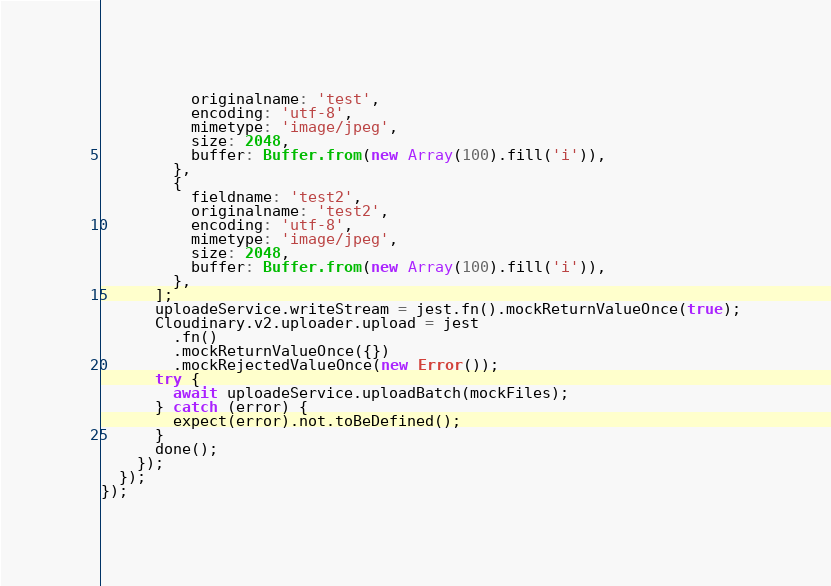Convert code to text. <code><loc_0><loc_0><loc_500><loc_500><_TypeScript_>          originalname: 'test',
          encoding: 'utf-8',
          mimetype: 'image/jpeg',
          size: 2048,
          buffer: Buffer.from(new Array(100).fill('i')),
        },
        {
          fieldname: 'test2',
          originalname: 'test2',
          encoding: 'utf-8',
          mimetype: 'image/jpeg',
          size: 2048,
          buffer: Buffer.from(new Array(100).fill('i')),
        },
      ];
      uploadeService.writeStream = jest.fn().mockReturnValueOnce(true);
      Cloudinary.v2.uploader.upload = jest
        .fn()
        .mockReturnValueOnce({})
        .mockRejectedValueOnce(new Error());
      try {
        await uploadeService.uploadBatch(mockFiles);
      } catch (error) {
        expect(error).not.toBeDefined();
      }
      done();
    });
  });
});
</code> 